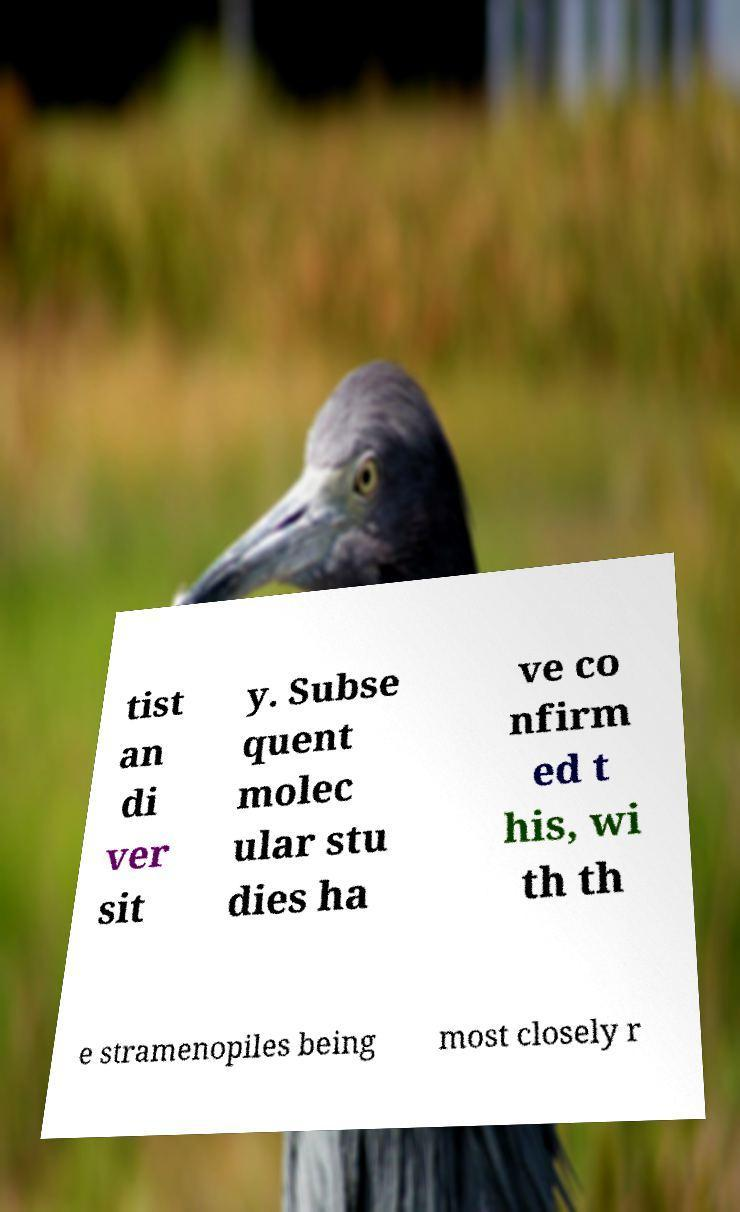Could you assist in decoding the text presented in this image and type it out clearly? tist an di ver sit y. Subse quent molec ular stu dies ha ve co nfirm ed t his, wi th th e stramenopiles being most closely r 